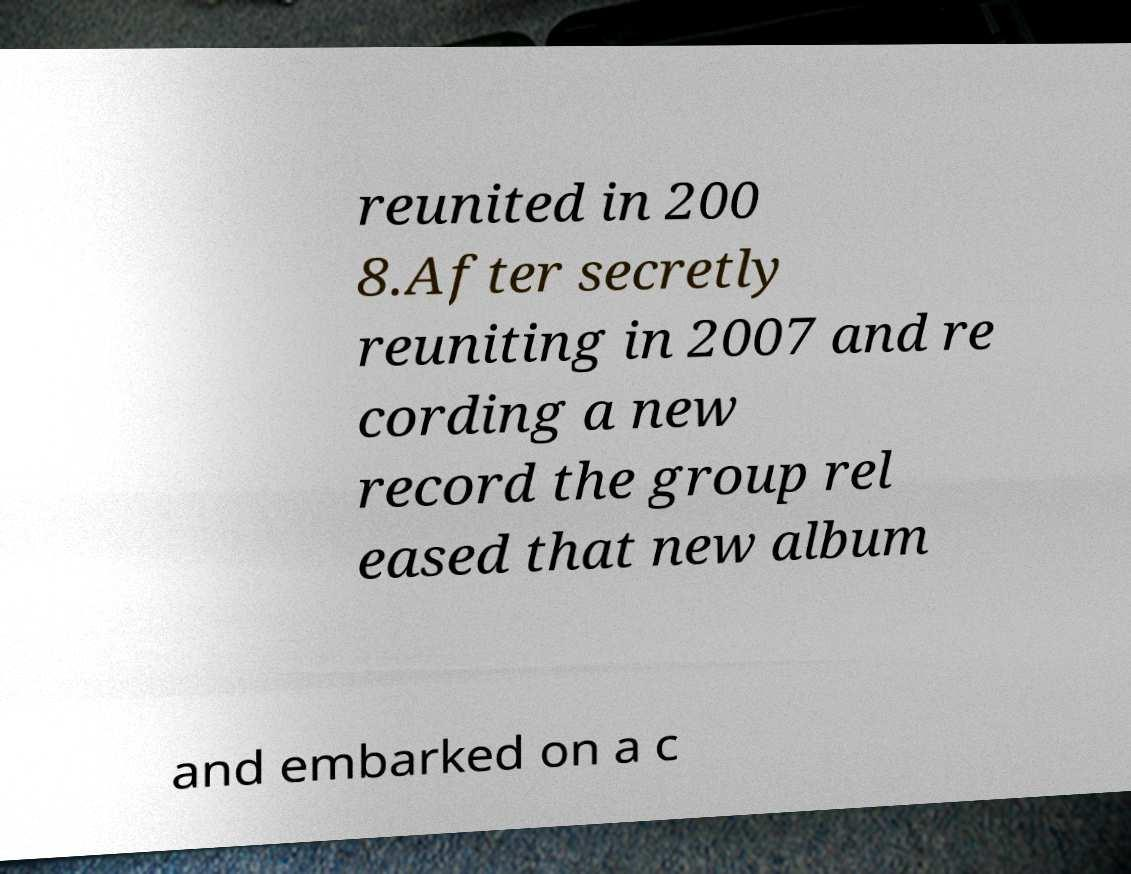Could you assist in decoding the text presented in this image and type it out clearly? reunited in 200 8.After secretly reuniting in 2007 and re cording a new record the group rel eased that new album and embarked on a c 